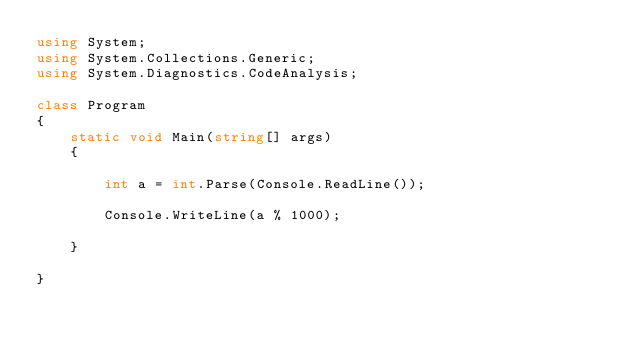Convert code to text. <code><loc_0><loc_0><loc_500><loc_500><_C#_>using System;
using System.Collections.Generic;
using System.Diagnostics.CodeAnalysis;

class Program
{
	static void Main(string[] args)
	{

		int a = int.Parse(Console.ReadLine());

		Console.WriteLine(a % 1000);

	}

}</code> 